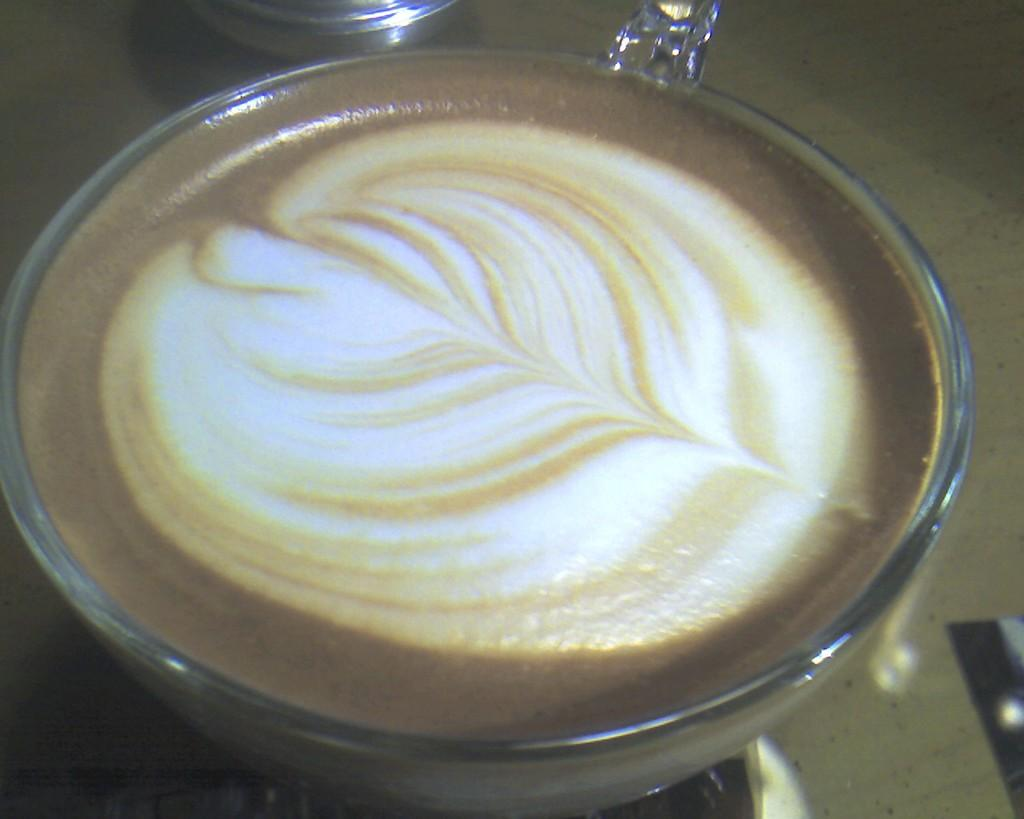What is in the cup that is visible in the image? The cup contains coffee. Where is the cup placed in the image? The cup is placed on a table. What type of voice can be heard coming from the cup in the image? There is no voice coming from the cup in the image, as it contains coffee and is not a sentient being. 